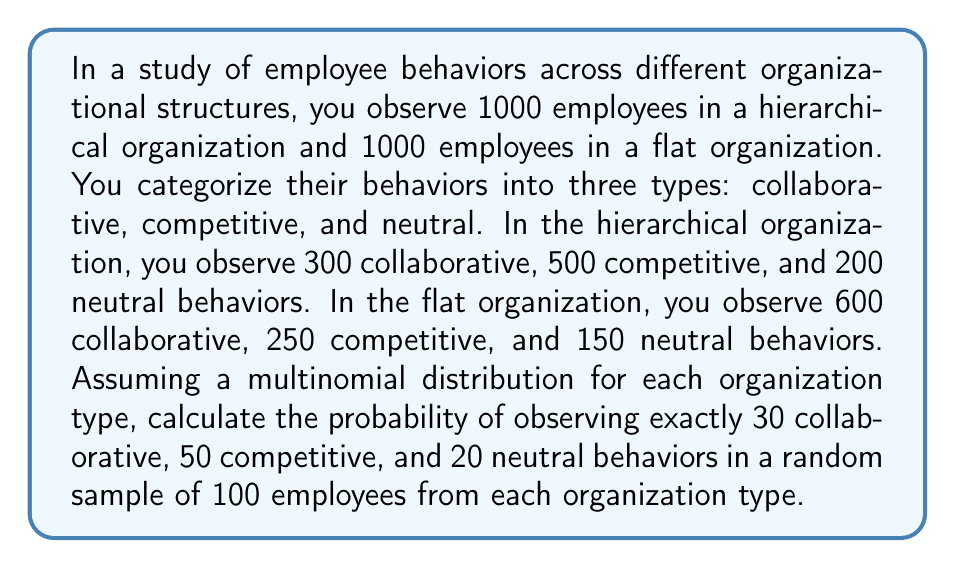Help me with this question. To solve this problem, we'll use the multinomial distribution for each organization type. The probability mass function for a multinomial distribution is given by:

$$ P(X_1 = x_1, X_2 = x_2, ..., X_k = x_k) = \frac{n!}{x_1! x_2! ... x_k!} p_1^{x_1} p_2^{x_2} ... p_k^{x_k} $$

Where $n$ is the total number of trials, $x_i$ is the number of occurrences of each outcome, and $p_i$ is the probability of each outcome.

Step 1: Calculate probabilities for each behavior type in each organization.

Hierarchical organization:
$p_{h,c} = 300/1000 = 0.3$ (collaborative)
$p_{h,m} = 500/1000 = 0.5$ (competitive)
$p_{h,n} = 200/1000 = 0.2$ (neutral)

Flat organization:
$p_{f,c} = 600/1000 = 0.6$ (collaborative)
$p_{f,m} = 250/1000 = 0.25$ (competitive)
$p_{f,n} = 150/1000 = 0.15$ (neutral)

Step 2: Apply the multinomial distribution formula for each organization type.

For hierarchical organization:
$$ P_h = \frac{100!}{30! 50! 20!} (0.3)^{30} (0.5)^{50} (0.2)^{20} $$

For flat organization:
$$ P_f = \frac{100!}{30! 50! 20!} (0.6)^{30} (0.25)^{50} (0.15)^{20} $$

Step 3: Calculate the probabilities using a calculator or computer software.

$P_h \approx 0.0112$
$P_f \approx 1.65 \times 10^{-12}$
Answer: Hierarchical: 0.0112, Flat: $1.65 \times 10^{-12}$ 